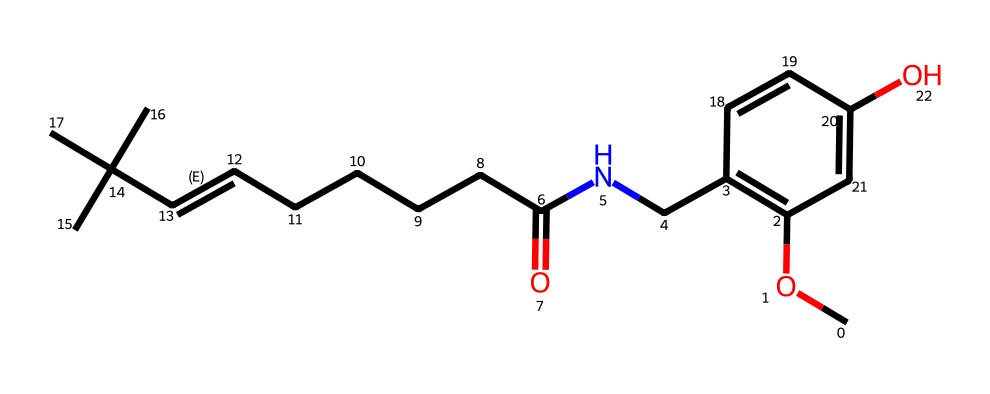how many carbon atoms are in capsaicin? By examining the SMILES structure, we can identify the number of carbon (C) atoms present. The structure indicates multiple sections, generally each 'C' indicates a carbon atom. Counting these gives a total of 18 carbon atoms present in the molecule.
Answer: 18 what functional groups are present in capsaicin? Looking at the SMILES representation, we can identify several functional groups based on their distinguishing features. There is an amide (C(=O)N) and hydroxyl group (–OH), which are visible in the structure. Thus, there are functional groups like amide and hydroxyl present.
Answer: amide, hydroxyl what type of bonding is primarily present in capsaicin? In examining the bonds present in the SMILES notation, it shows a combination of single bonds and one double bond (C=C). Based on the overall structure, the predominant type of bonding in this molecule is single covalent bonds.
Answer: single covalent bonds what is the molecular weight of capsaicin? To calculate the molecular weight, we can tally the atomic weights of all the elements present in the structure. The counts are as follows: 18 carbons (18×12.01), 27 hydrogens (27×1.008), 2 nitrogens (2×14.01), and 3 oxygens (3×16.00). Summing these yields a molecular weight of approximately 305.42 g/mol.
Answer: 305.42 which element in the structure contributes to its pungency? Capsaicin is known for its pungent taste, which largely comes from the presence of the nitrogen atom (–N). The nitrogen atom is part of the amide group, which contributes to the characteristic spiciness.
Answer: nitrogen 